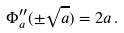<formula> <loc_0><loc_0><loc_500><loc_500>\Phi ^ { \prime \prime } _ { a } ( \pm \sqrt { a } ) = 2 a \, .</formula> 